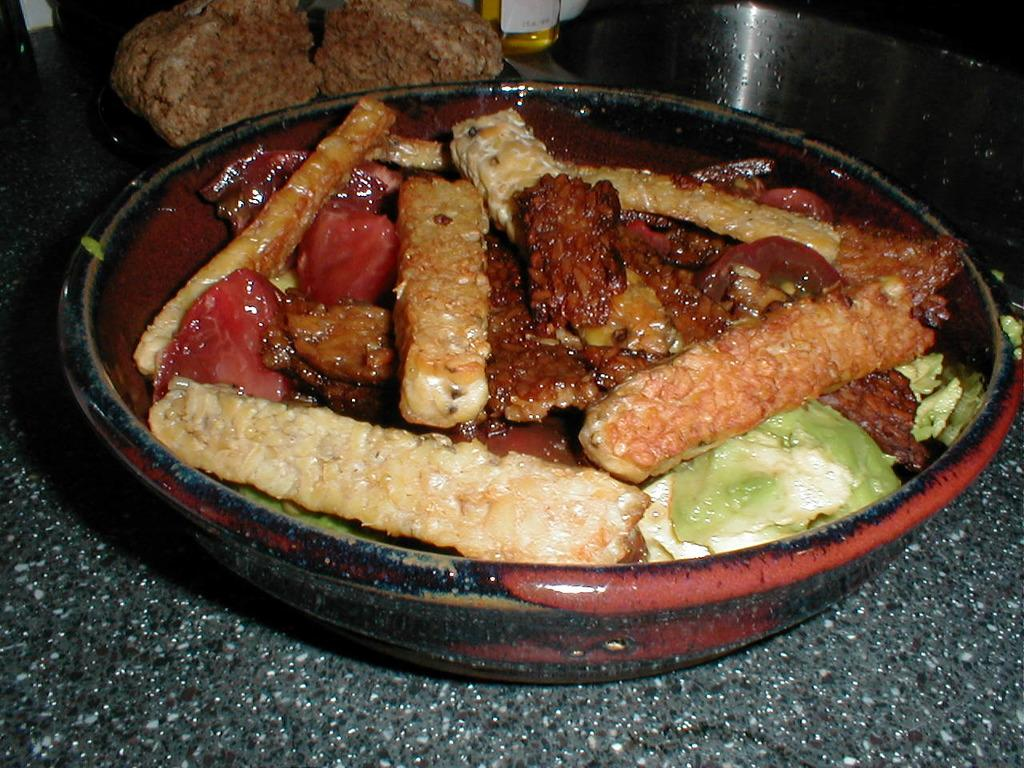What type of food can be seen in the image? The image contains food, but the specific type cannot be determined from the provided facts. What colors are present in the food? The food has brown, red, and green colors. What is the color of the bowl containing the food? The bowl is in black and brown colors. How many members are on the committee in the image? There is no committee present in the image. Is the person in the image sleeping? There is no person present in the image. 